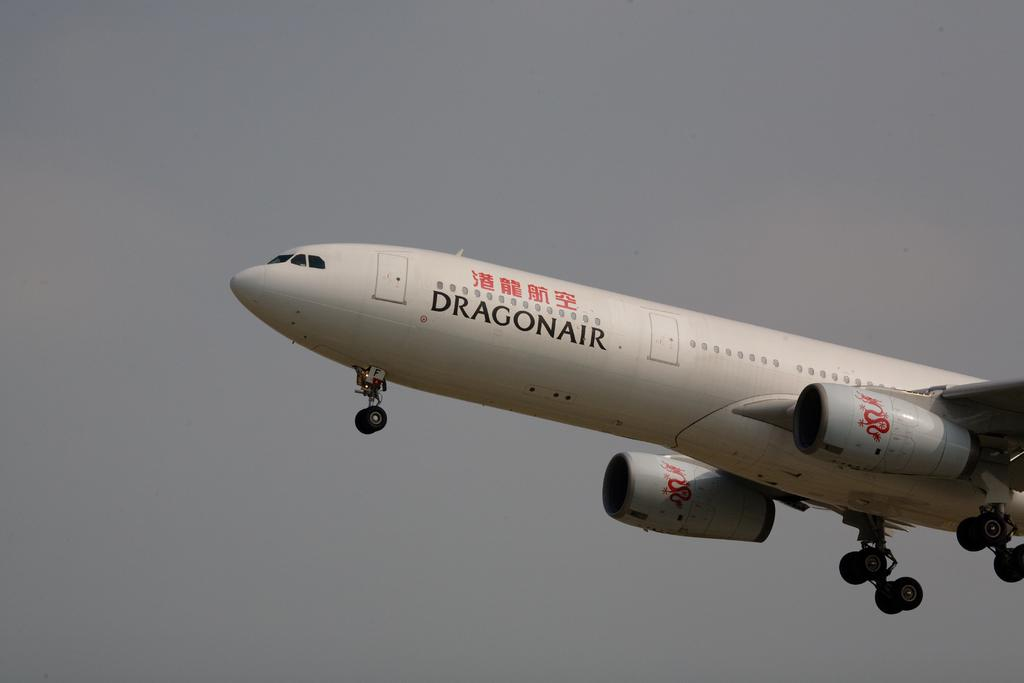What is the color of the airplane in the image? The airplane is white in the image. What is the airplane doing in the image? The airplane is flying in the air. What can be seen in the background of the image? There are clouds in the sky in the background of the image. Where is the goat playing in the image? There is no goat present in the image. How many clocks can be seen in the image? There are no clocks visible in the image. 